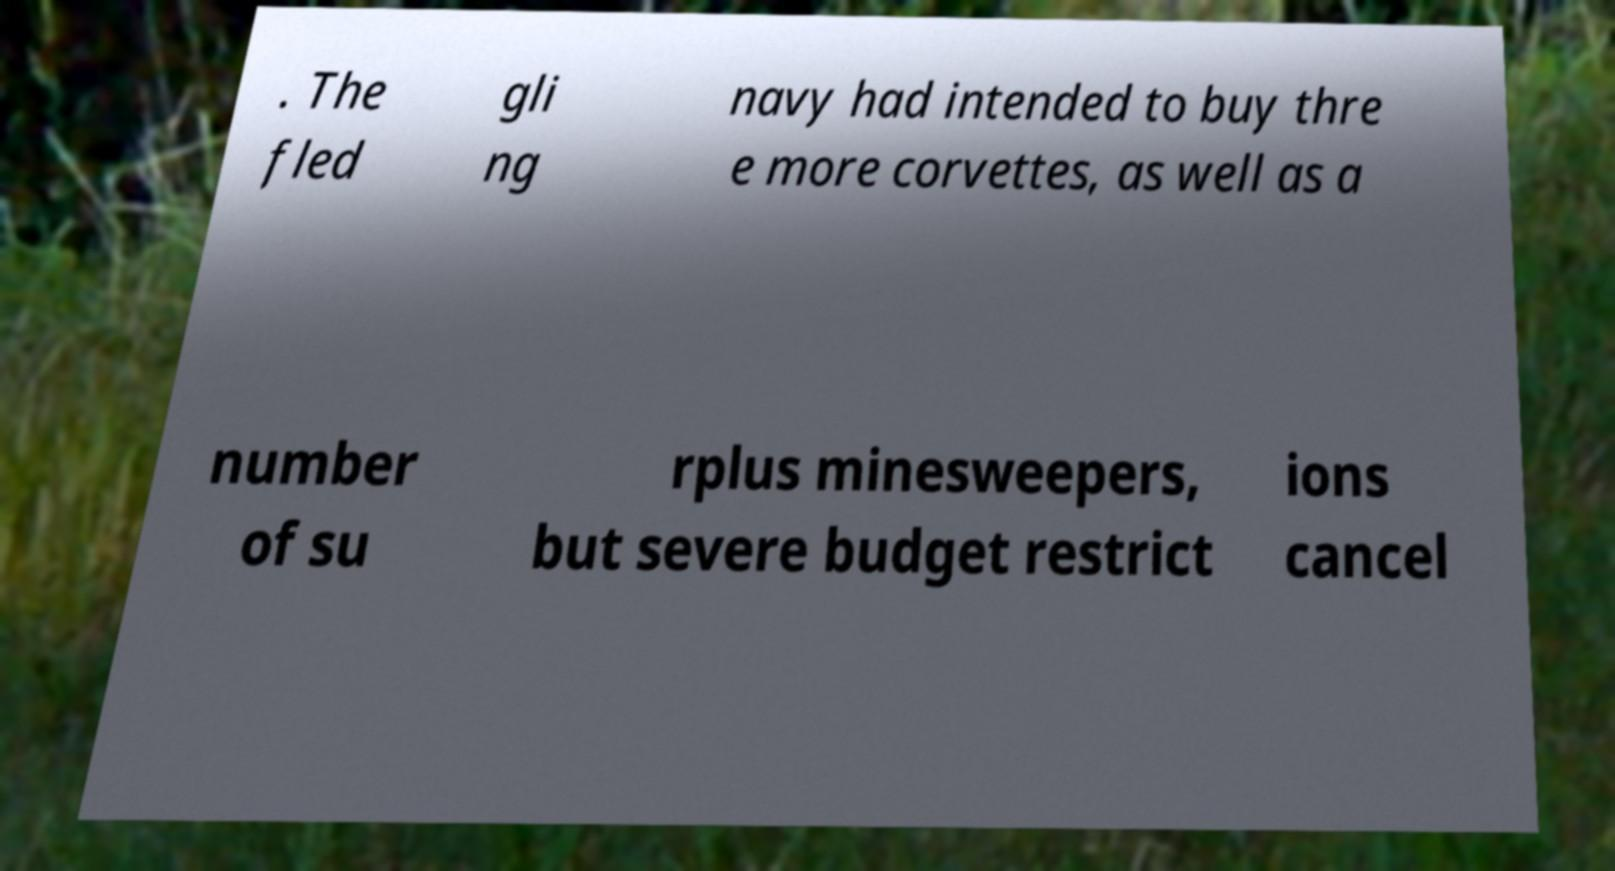There's text embedded in this image that I need extracted. Can you transcribe it verbatim? . The fled gli ng navy had intended to buy thre e more corvettes, as well as a number of su rplus minesweepers, but severe budget restrict ions cancel 